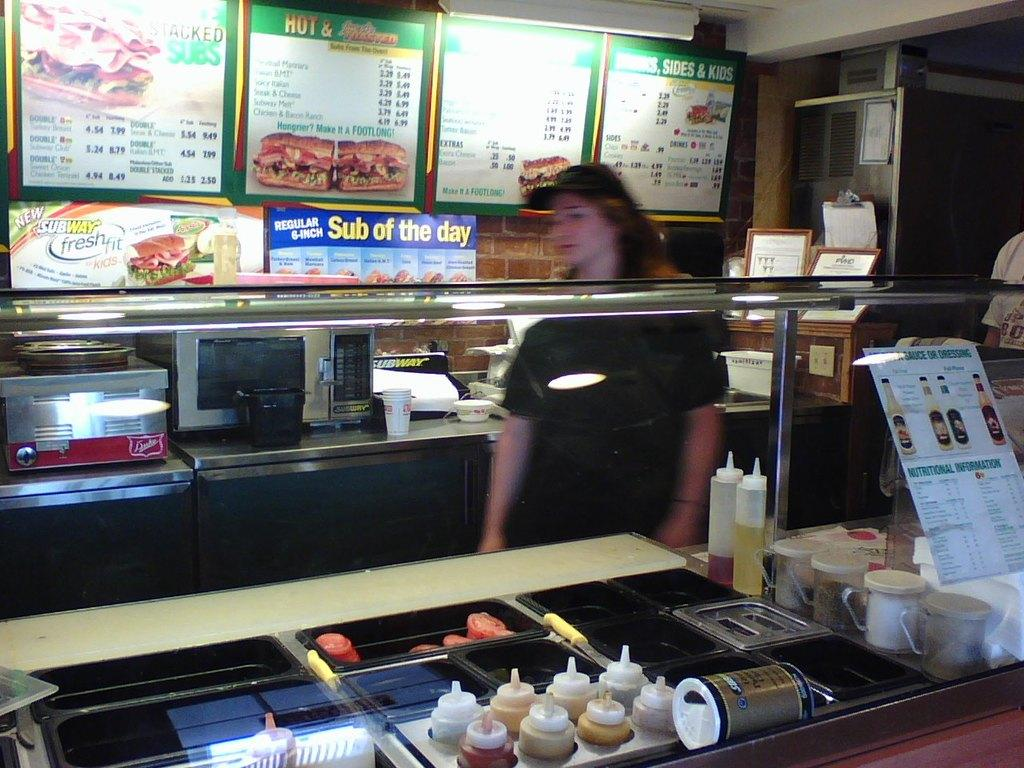<image>
Offer a succinct explanation of the picture presented. Sub of the day from Subway, which says Regular 6-inch. 